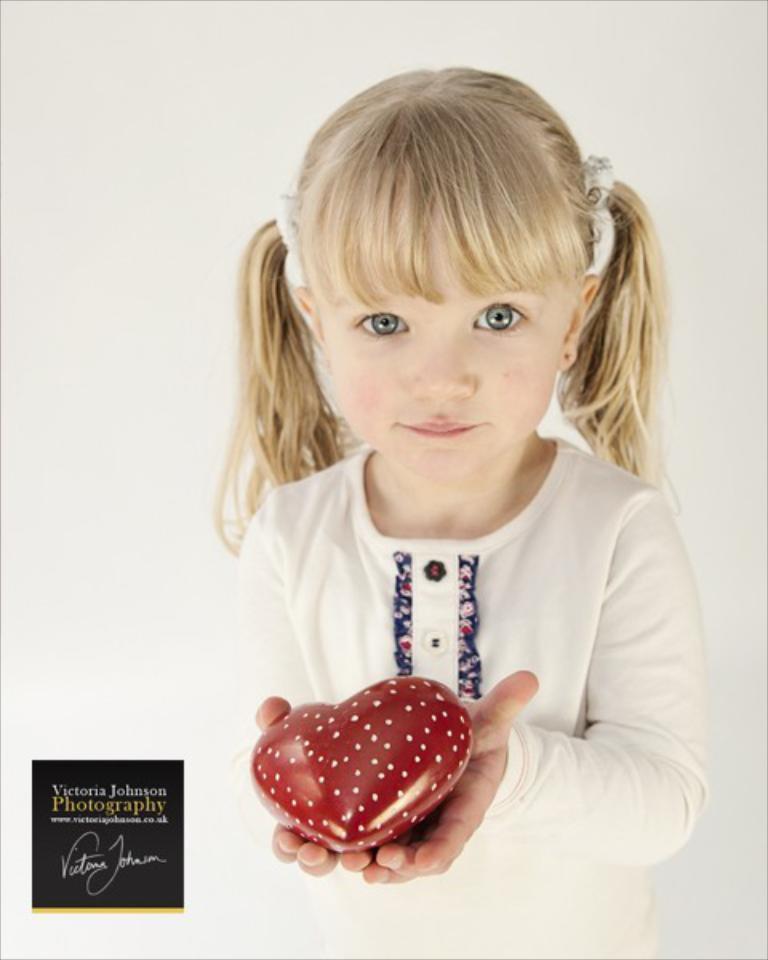Please provide a concise description of this image. In this image, we can see a girl standing and she is holding a red color object, there is a white color background. 